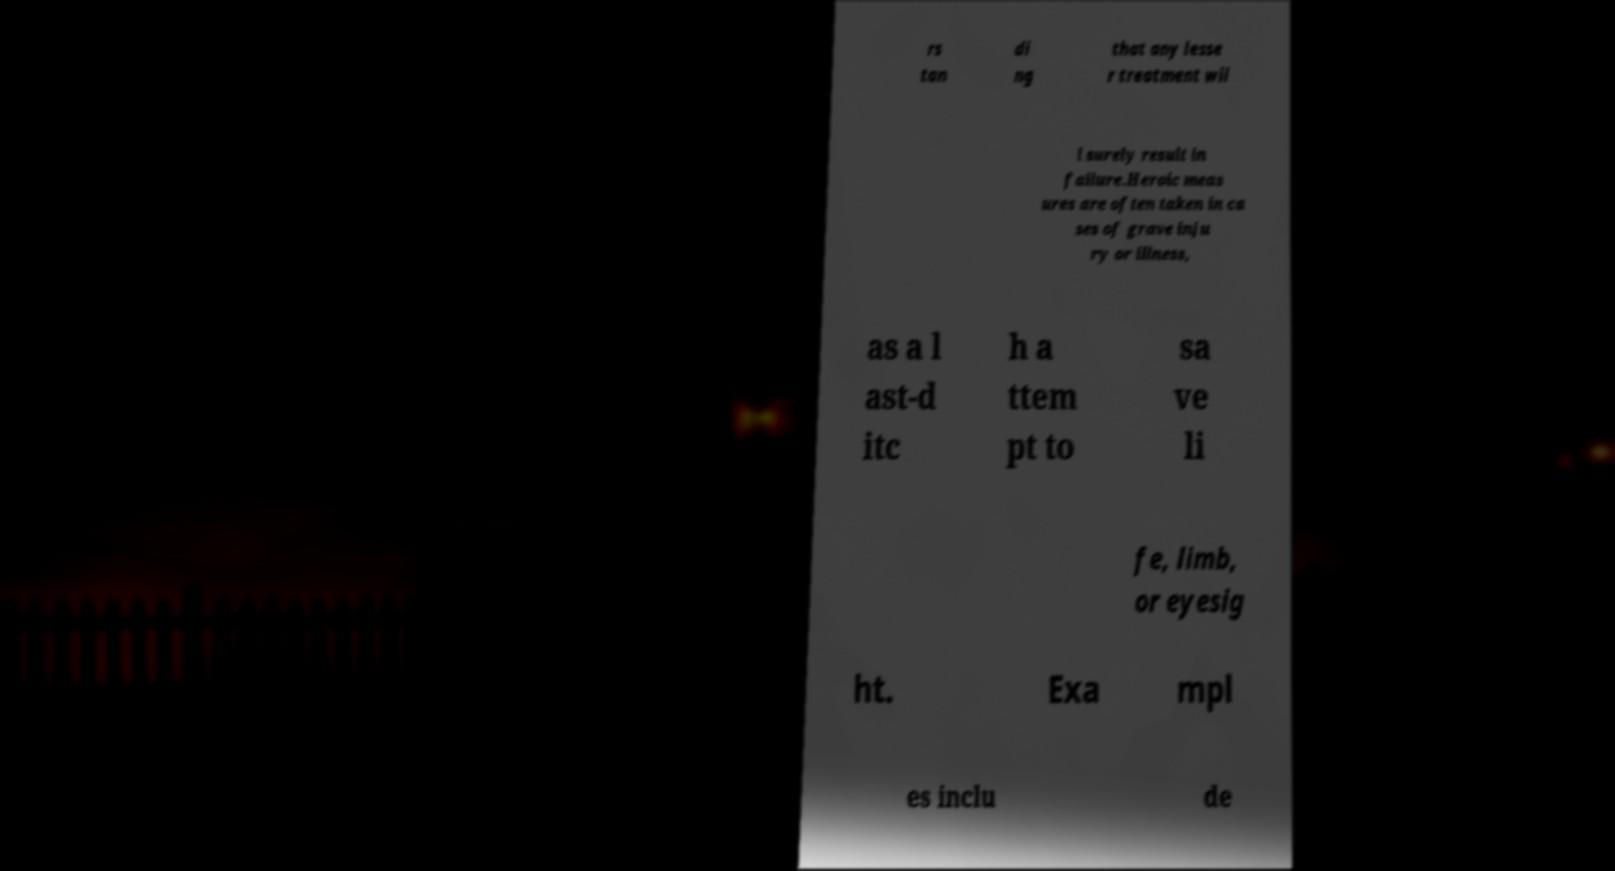Please read and relay the text visible in this image. What does it say? rs tan di ng that any lesse r treatment wil l surely result in failure.Heroic meas ures are often taken in ca ses of grave inju ry or illness, as a l ast-d itc h a ttem pt to sa ve li fe, limb, or eyesig ht. Exa mpl es inclu de 